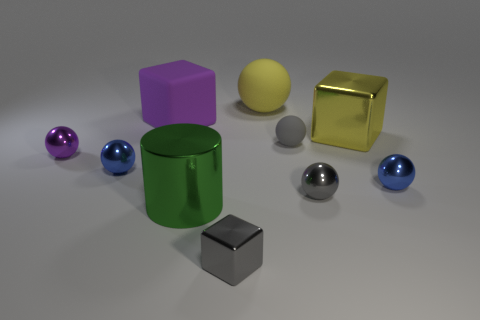There is a thing that is the same color as the big metal block; what is its size?
Offer a very short reply. Large. There is a big object in front of the large yellow metal object; what is its color?
Provide a succinct answer. Green. Is the number of big matte things in front of the small gray rubber object greater than the number of gray shiny spheres?
Offer a very short reply. No. Do the small purple thing and the yellow ball have the same material?
Provide a succinct answer. No. How many other things are the same shape as the small rubber object?
Keep it short and to the point. 5. Are there any other things that have the same material as the purple sphere?
Your answer should be very brief. Yes. The cube right of the small gray sphere that is in front of the small blue object on the left side of the tiny shiny cube is what color?
Keep it short and to the point. Yellow. There is a tiny gray metallic object that is on the left side of the yellow sphere; does it have the same shape as the big purple rubber thing?
Ensure brevity in your answer.  Yes. What number of large blocks are there?
Make the answer very short. 2. How many purple cubes have the same size as the cylinder?
Your answer should be compact. 1. 